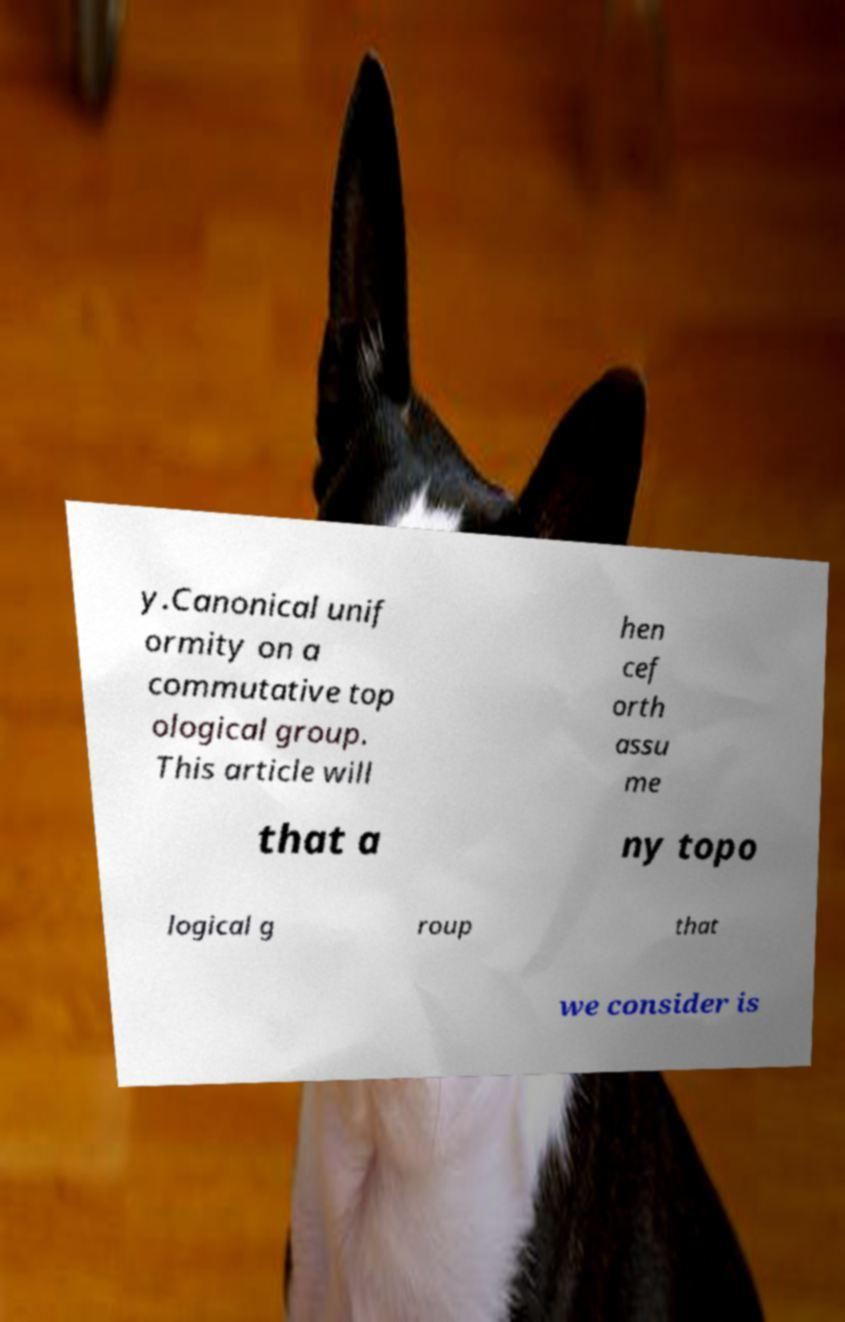Please identify and transcribe the text found in this image. y.Canonical unif ormity on a commutative top ological group. This article will hen cef orth assu me that a ny topo logical g roup that we consider is 